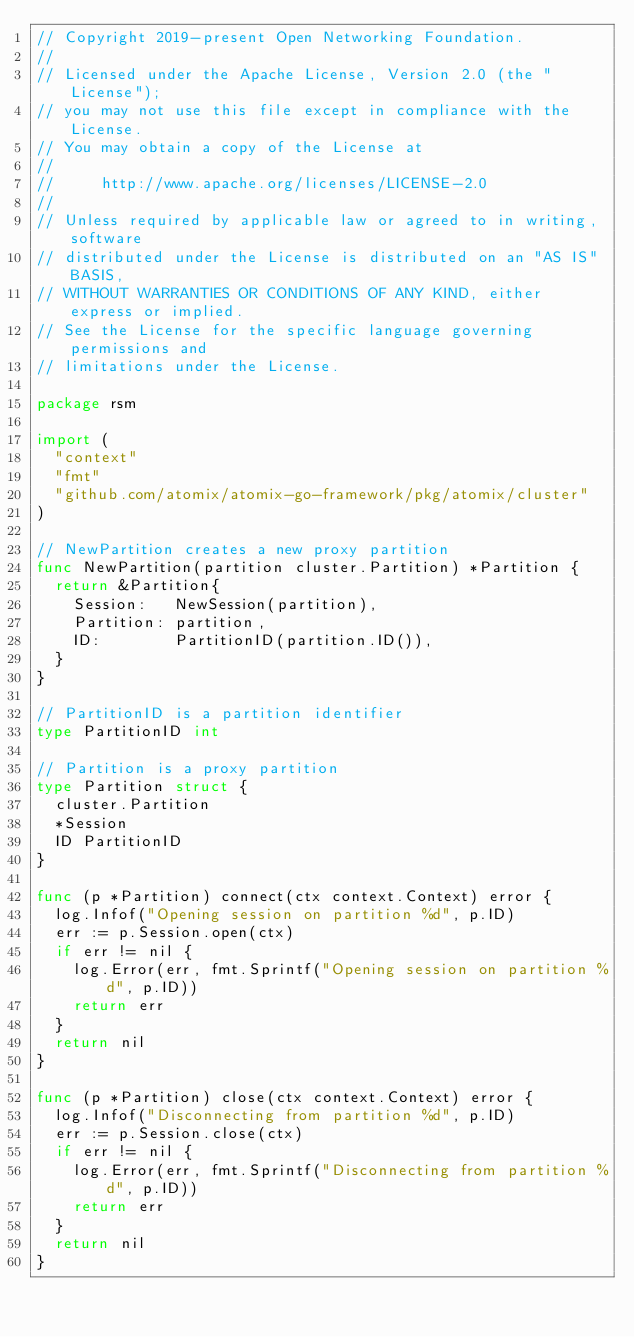<code> <loc_0><loc_0><loc_500><loc_500><_Go_>// Copyright 2019-present Open Networking Foundation.
//
// Licensed under the Apache License, Version 2.0 (the "License");
// you may not use this file except in compliance with the License.
// You may obtain a copy of the License at
//
//     http://www.apache.org/licenses/LICENSE-2.0
//
// Unless required by applicable law or agreed to in writing, software
// distributed under the License is distributed on an "AS IS" BASIS,
// WITHOUT WARRANTIES OR CONDITIONS OF ANY KIND, either express or implied.
// See the License for the specific language governing permissions and
// limitations under the License.

package rsm

import (
	"context"
	"fmt"
	"github.com/atomix/atomix-go-framework/pkg/atomix/cluster"
)

// NewPartition creates a new proxy partition
func NewPartition(partition cluster.Partition) *Partition {
	return &Partition{
		Session:   NewSession(partition),
		Partition: partition,
		ID:        PartitionID(partition.ID()),
	}
}

// PartitionID is a partition identifier
type PartitionID int

// Partition is a proxy partition
type Partition struct {
	cluster.Partition
	*Session
	ID PartitionID
}

func (p *Partition) connect(ctx context.Context) error {
	log.Infof("Opening session on partition %d", p.ID)
	err := p.Session.open(ctx)
	if err != nil {
		log.Error(err, fmt.Sprintf("Opening session on partition %d", p.ID))
		return err
	}
	return nil
}

func (p *Partition) close(ctx context.Context) error {
	log.Infof("Disconnecting from partition %d", p.ID)
	err := p.Session.close(ctx)
	if err != nil {
		log.Error(err, fmt.Sprintf("Disconnecting from partition %d", p.ID))
		return err
	}
	return nil
}
</code> 